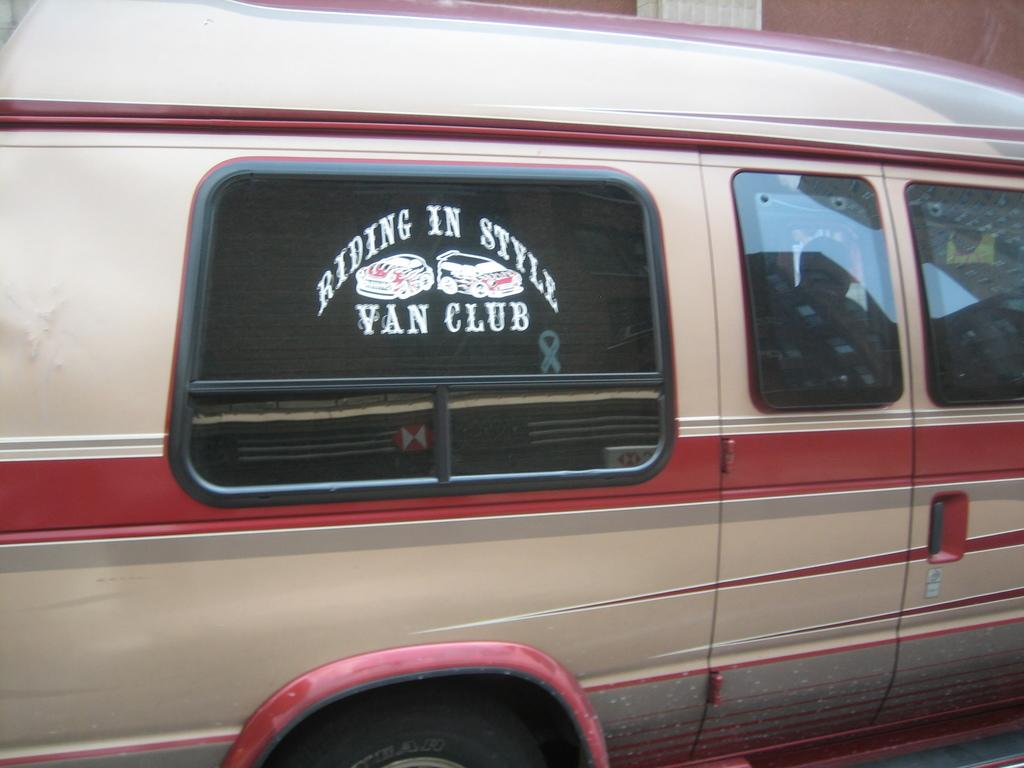Provide a one-sentence caption for the provided image. A van has "Riding in Style Van Club" stenciled on the window. 